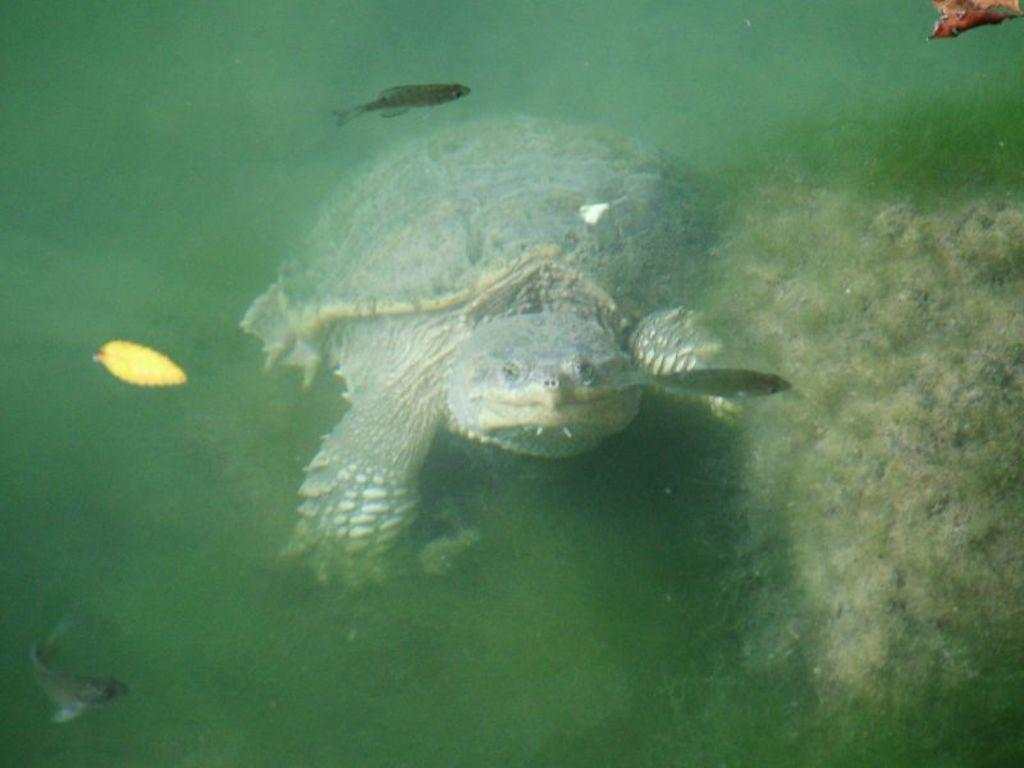What type of animal is in the image? There is a tortoise in the image. What other living creatures can be seen in the image? There are fishes in the image. What type of vegetation is present in the image? There are leaves in the image. Can you describe the environment in the image? The image might depict a marine environment, as there are fishes and possibly a marine plant in the water. What type of bean is being used as a fan in the image? There is no bean or fan present in the image. 